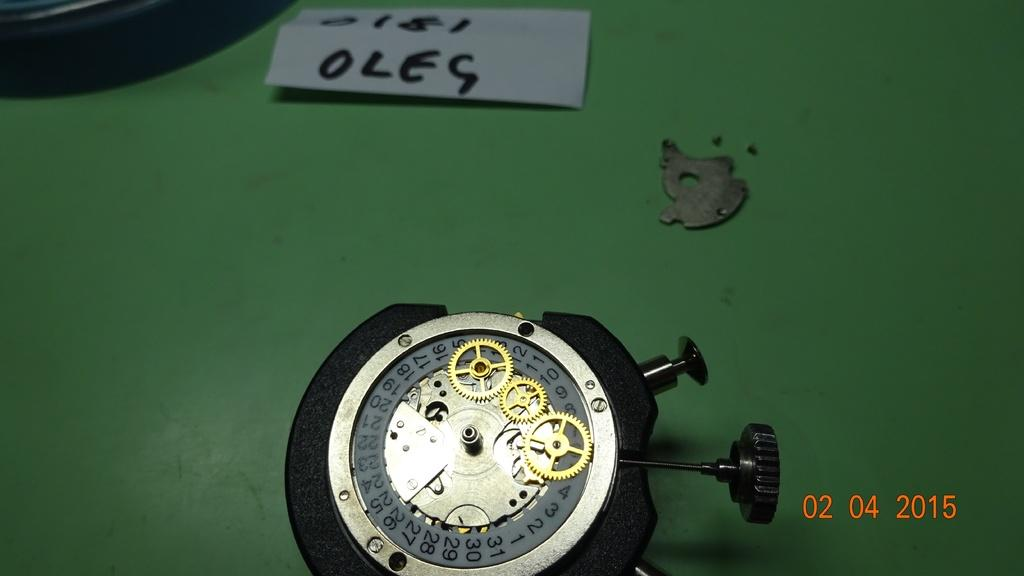<image>
Provide a brief description of the given image. The inside of a watch with gears showing and a paper that says Oleg on it. 